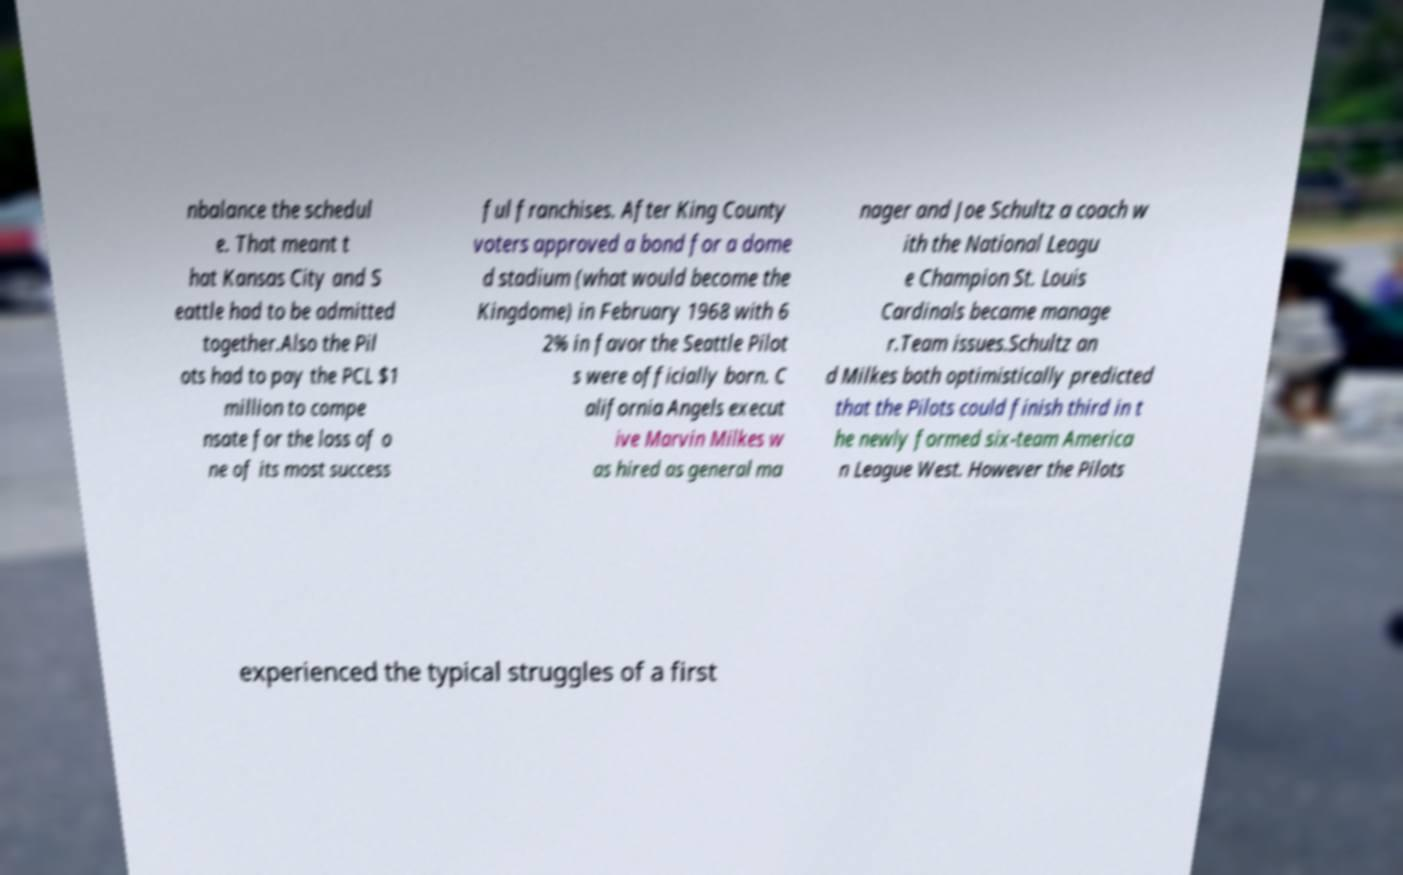Can you accurately transcribe the text from the provided image for me? nbalance the schedul e. That meant t hat Kansas City and S eattle had to be admitted together.Also the Pil ots had to pay the PCL $1 million to compe nsate for the loss of o ne of its most success ful franchises. After King County voters approved a bond for a dome d stadium (what would become the Kingdome) in February 1968 with 6 2% in favor the Seattle Pilot s were officially born. C alifornia Angels execut ive Marvin Milkes w as hired as general ma nager and Joe Schultz a coach w ith the National Leagu e Champion St. Louis Cardinals became manage r.Team issues.Schultz an d Milkes both optimistically predicted that the Pilots could finish third in t he newly formed six-team America n League West. However the Pilots experienced the typical struggles of a first 